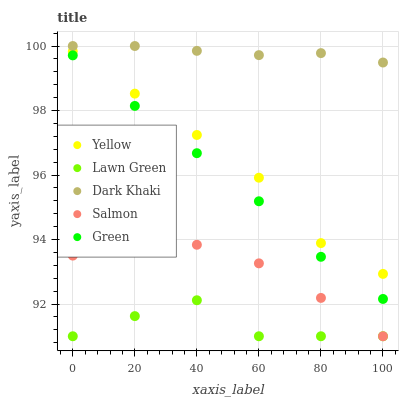Does Lawn Green have the minimum area under the curve?
Answer yes or no. Yes. Does Dark Khaki have the maximum area under the curve?
Answer yes or no. Yes. Does Green have the minimum area under the curve?
Answer yes or no. No. Does Green have the maximum area under the curve?
Answer yes or no. No. Is Dark Khaki the smoothest?
Answer yes or no. Yes. Is Lawn Green the roughest?
Answer yes or no. Yes. Is Green the smoothest?
Answer yes or no. No. Is Green the roughest?
Answer yes or no. No. Does Lawn Green have the lowest value?
Answer yes or no. Yes. Does Green have the lowest value?
Answer yes or no. No. Does Dark Khaki have the highest value?
Answer yes or no. Yes. Does Green have the highest value?
Answer yes or no. No. Is Green less than Yellow?
Answer yes or no. Yes. Is Green greater than Salmon?
Answer yes or no. Yes. Does Salmon intersect Lawn Green?
Answer yes or no. Yes. Is Salmon less than Lawn Green?
Answer yes or no. No. Is Salmon greater than Lawn Green?
Answer yes or no. No. Does Green intersect Yellow?
Answer yes or no. No. 